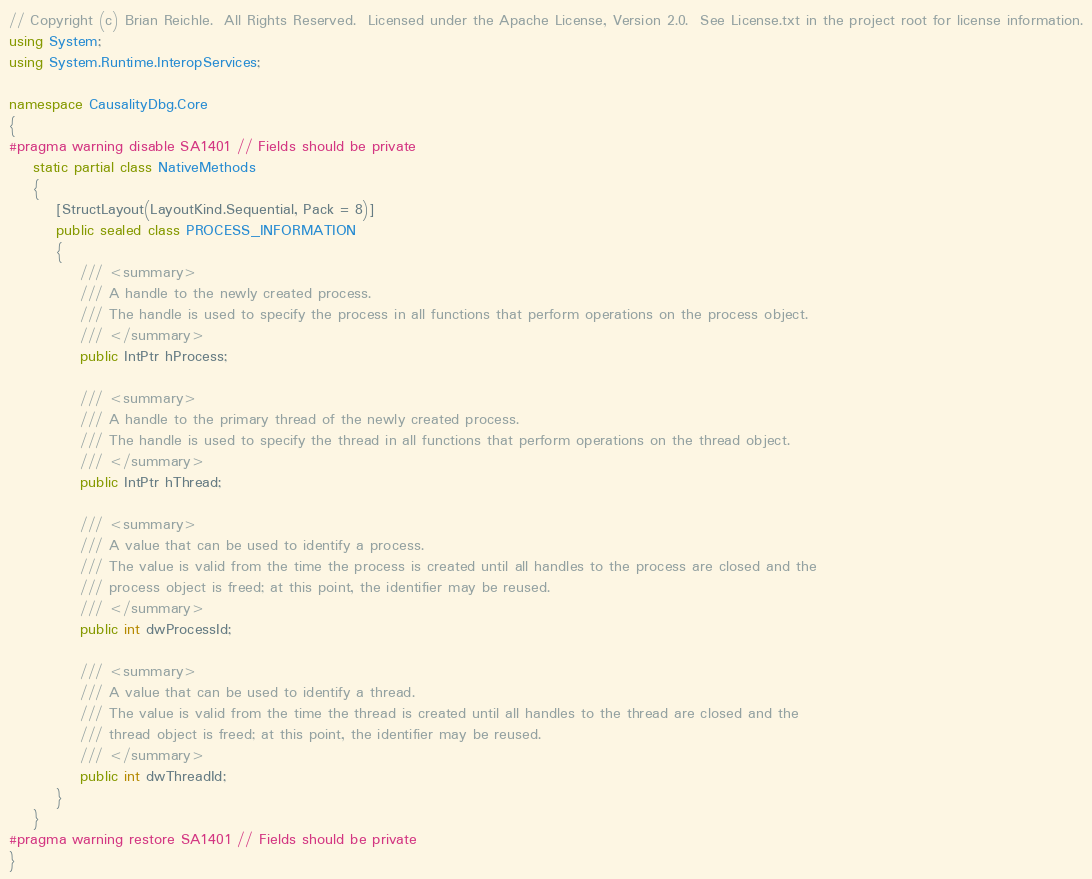Convert code to text. <code><loc_0><loc_0><loc_500><loc_500><_C#_>// Copyright (c) Brian Reichle.  All Rights Reserved.  Licensed under the Apache License, Version 2.0.  See License.txt in the project root for license information.
using System;
using System.Runtime.InteropServices;

namespace CausalityDbg.Core
{
#pragma warning disable SA1401 // Fields should be private
	static partial class NativeMethods
	{
		[StructLayout(LayoutKind.Sequential, Pack = 8)]
		public sealed class PROCESS_INFORMATION
		{
			/// <summary>
			/// A handle to the newly created process.
			/// The handle is used to specify the process in all functions that perform operations on the process object.
			/// </summary>
			public IntPtr hProcess;

			/// <summary>
			/// A handle to the primary thread of the newly created process.
			/// The handle is used to specify the thread in all functions that perform operations on the thread object.
			/// </summary>
			public IntPtr hThread;

			/// <summary>
			/// A value that can be used to identify a process.
			/// The value is valid from the time the process is created until all handles to the process are closed and the
			/// process object is freed; at this point, the identifier may be reused.
			/// </summary>
			public int dwProcessId;

			/// <summary>
			/// A value that can be used to identify a thread.
			/// The value is valid from the time the thread is created until all handles to the thread are closed and the
			/// thread object is freed; at this point, the identifier may be reused.
			/// </summary>
			public int dwThreadId;
		}
	}
#pragma warning restore SA1401 // Fields should be private
}
</code> 